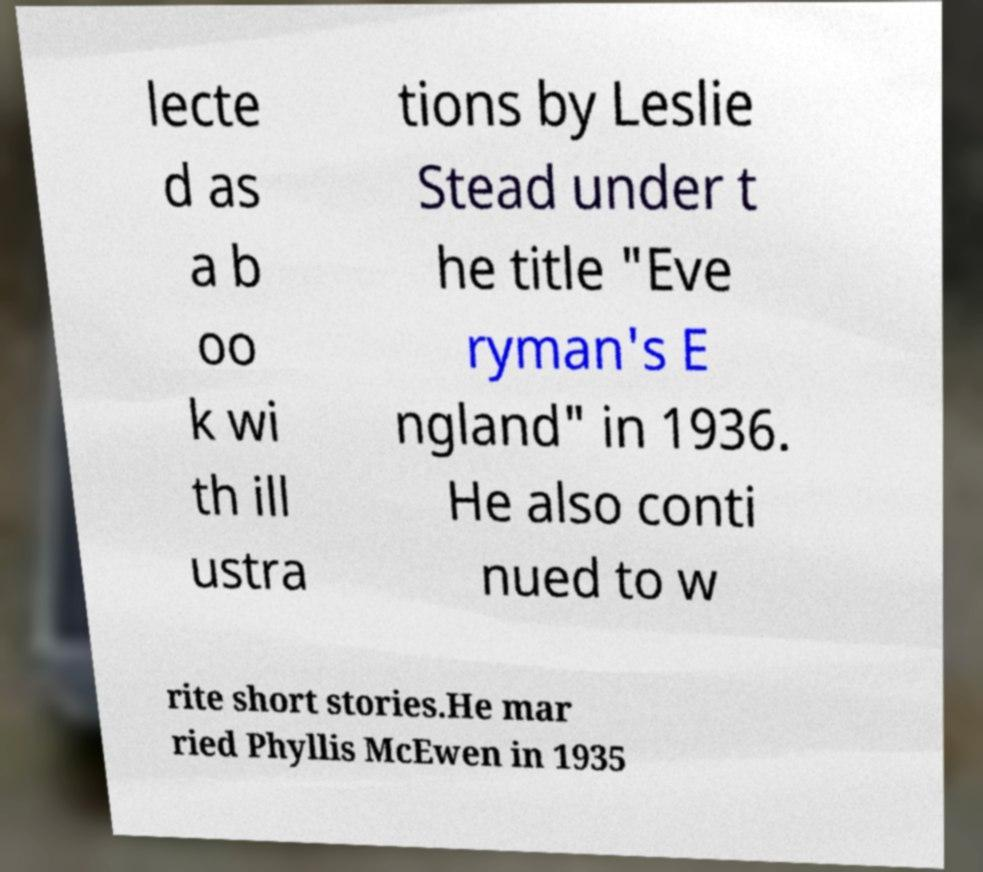Please read and relay the text visible in this image. What does it say? lecte d as a b oo k wi th ill ustra tions by Leslie Stead under t he title "Eve ryman's E ngland" in 1936. He also conti nued to w rite short stories.He mar ried Phyllis McEwen in 1935 